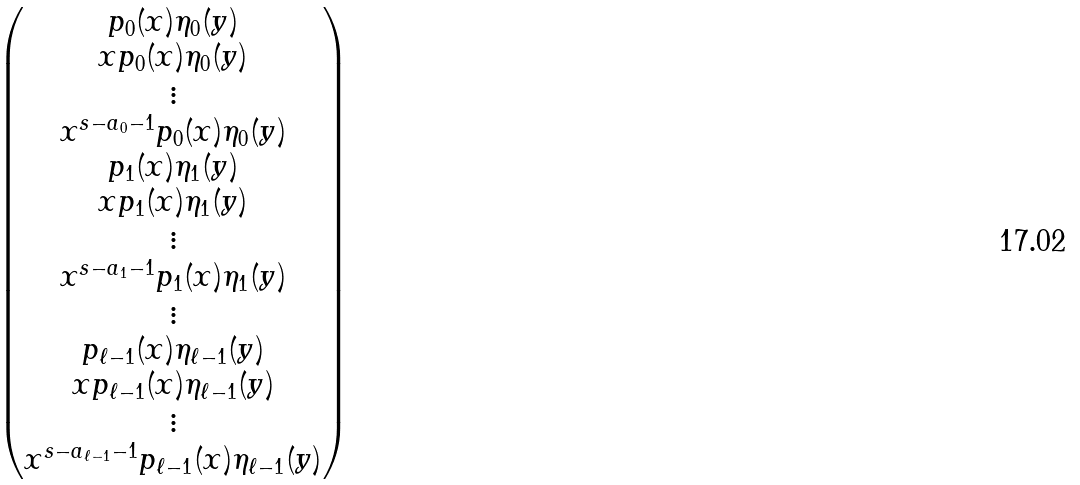Convert formula to latex. <formula><loc_0><loc_0><loc_500><loc_500>\begin{pmatrix} p _ { 0 } ( x ) \eta _ { 0 } ( y ) \\ x p _ { 0 } ( x ) \eta _ { 0 } ( y ) \\ \vdots \\ x ^ { s - a _ { 0 } - 1 } p _ { 0 } ( x ) \eta _ { 0 } ( y ) \\ p _ { 1 } ( x ) \eta _ { 1 } ( y ) \\ x p _ { 1 } ( x ) \eta _ { 1 } ( y ) \\ \vdots \\ x ^ { s - a _ { 1 } - 1 } p _ { 1 } ( x ) \eta _ { 1 } ( y ) \\ \vdots \\ p _ { \ell - 1 } ( x ) \eta _ { \ell - 1 } ( y ) \\ x p _ { \ell - 1 } ( x ) \eta _ { \ell - 1 } ( y ) \\ \vdots \\ x ^ { s - a _ { \ell - 1 } - 1 } p _ { \ell - 1 } ( x ) \eta _ { \ell - 1 } ( y ) \end{pmatrix}</formula> 